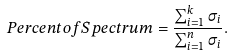Convert formula to latex. <formula><loc_0><loc_0><loc_500><loc_500>P e r c e n t o f S p e c t r u m = \frac { \sum _ { i = 1 } ^ { k } \sigma _ { i } } { \sum _ { i = 1 } ^ { n } \sigma _ { i } } .</formula> 